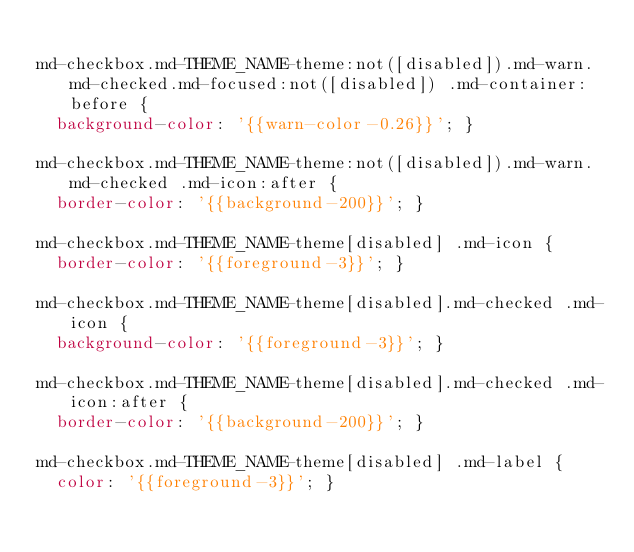Convert code to text. <code><loc_0><loc_0><loc_500><loc_500><_CSS_>
md-checkbox.md-THEME_NAME-theme:not([disabled]).md-warn.md-checked.md-focused:not([disabled]) .md-container:before {
  background-color: '{{warn-color-0.26}}'; }

md-checkbox.md-THEME_NAME-theme:not([disabled]).md-warn.md-checked .md-icon:after {
  border-color: '{{background-200}}'; }

md-checkbox.md-THEME_NAME-theme[disabled] .md-icon {
  border-color: '{{foreground-3}}'; }

md-checkbox.md-THEME_NAME-theme[disabled].md-checked .md-icon {
  background-color: '{{foreground-3}}'; }

md-checkbox.md-THEME_NAME-theme[disabled].md-checked .md-icon:after {
  border-color: '{{background-200}}'; }

md-checkbox.md-THEME_NAME-theme[disabled] .md-label {
  color: '{{foreground-3}}'; }
</code> 